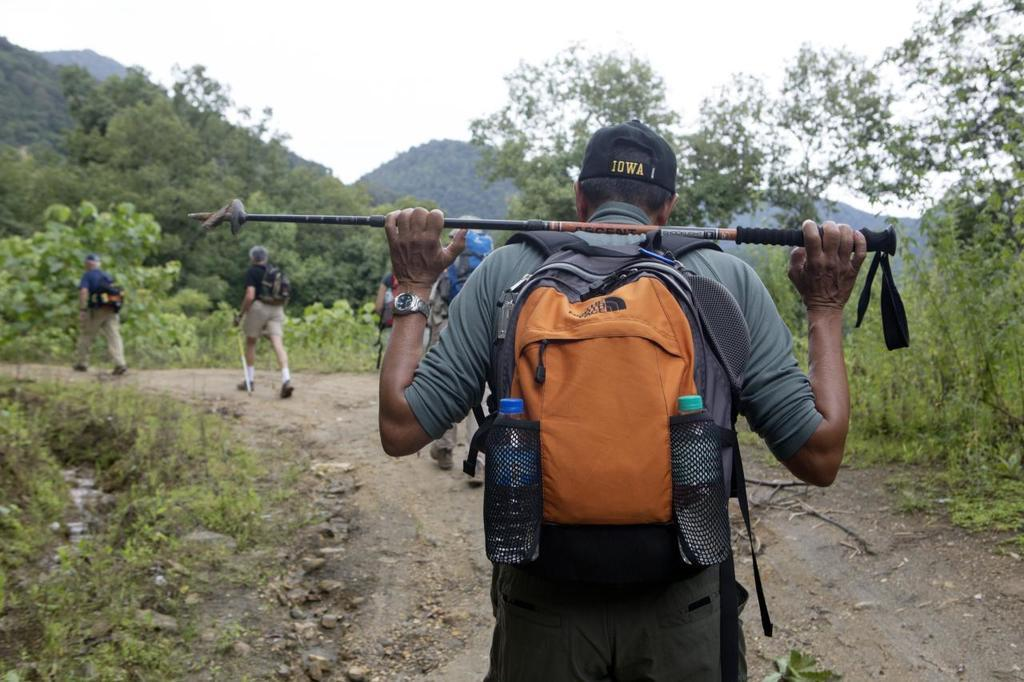<image>
Provide a brief description of the given image. A man with an Iowa hat his hiking and holding a ski pole 